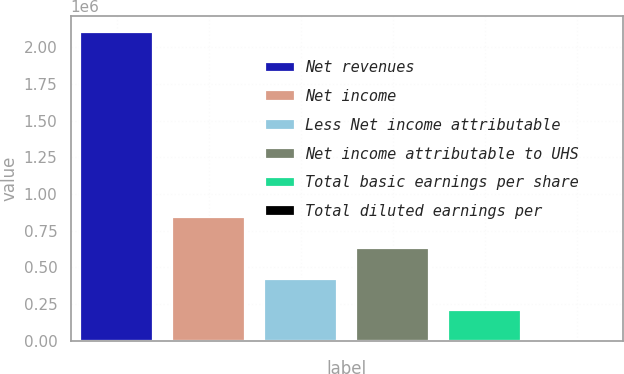<chart> <loc_0><loc_0><loc_500><loc_500><bar_chart><fcel>Net revenues<fcel>Net income<fcel>Less Net income attributable<fcel>Net income attributable to UHS<fcel>Total basic earnings per share<fcel>Total diluted earnings per<nl><fcel>2.10758e+06<fcel>843033<fcel>421518<fcel>632276<fcel>210760<fcel>1.71<nl></chart> 